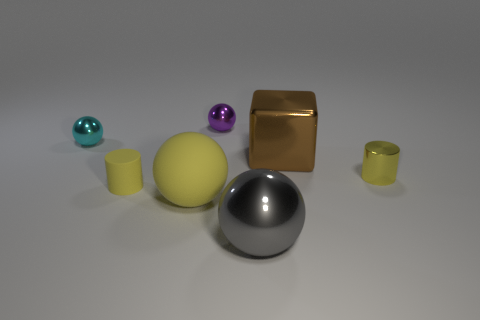How many objects are either yellow things that are right of the brown cube or yellow objects that are to the left of the big block?
Your response must be concise. 3. Is the material of the small yellow thing that is to the left of the metal cube the same as the small ball to the left of the small purple metal ball?
Offer a very short reply. No. What is the shape of the tiny yellow thing that is left of the small metallic thing in front of the brown block?
Your response must be concise. Cylinder. Is there any other thing that has the same color as the big rubber ball?
Your response must be concise. Yes. Is there a matte cylinder behind the metal ball that is to the left of the small ball that is behind the tiny cyan metal object?
Make the answer very short. No. Is the color of the small metallic ball that is behind the cyan shiny sphere the same as the small cylinder left of the purple sphere?
Provide a succinct answer. No. There is a sphere that is the same size as the cyan object; what is it made of?
Provide a succinct answer. Metal. There is a yellow thing that is on the right side of the big metallic thing behind the tiny cylinder that is left of the purple ball; what size is it?
Your answer should be compact. Small. What number of other things are there of the same material as the gray sphere
Ensure brevity in your answer.  4. There is a metallic object in front of the tiny yellow metallic object; what size is it?
Your response must be concise. Large. 